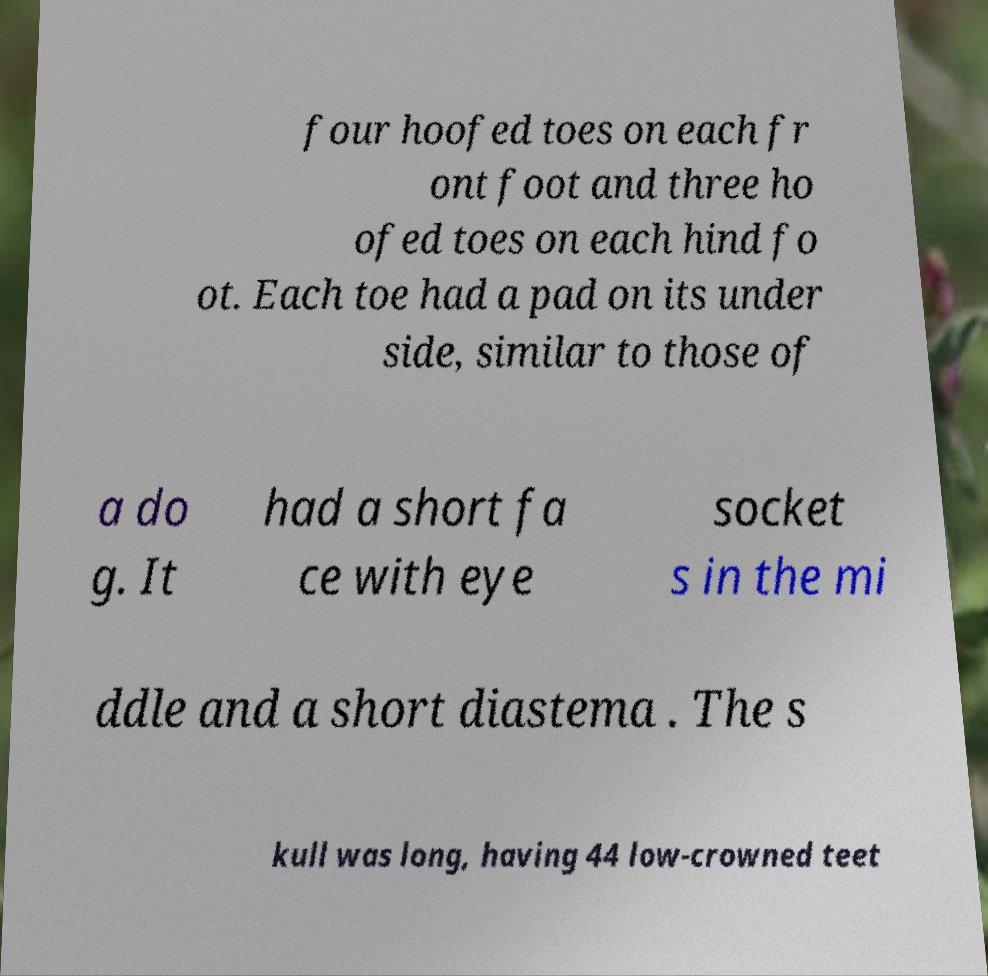Can you read and provide the text displayed in the image?This photo seems to have some interesting text. Can you extract and type it out for me? four hoofed toes on each fr ont foot and three ho ofed toes on each hind fo ot. Each toe had a pad on its under side, similar to those of a do g. It had a short fa ce with eye socket s in the mi ddle and a short diastema . The s kull was long, having 44 low-crowned teet 